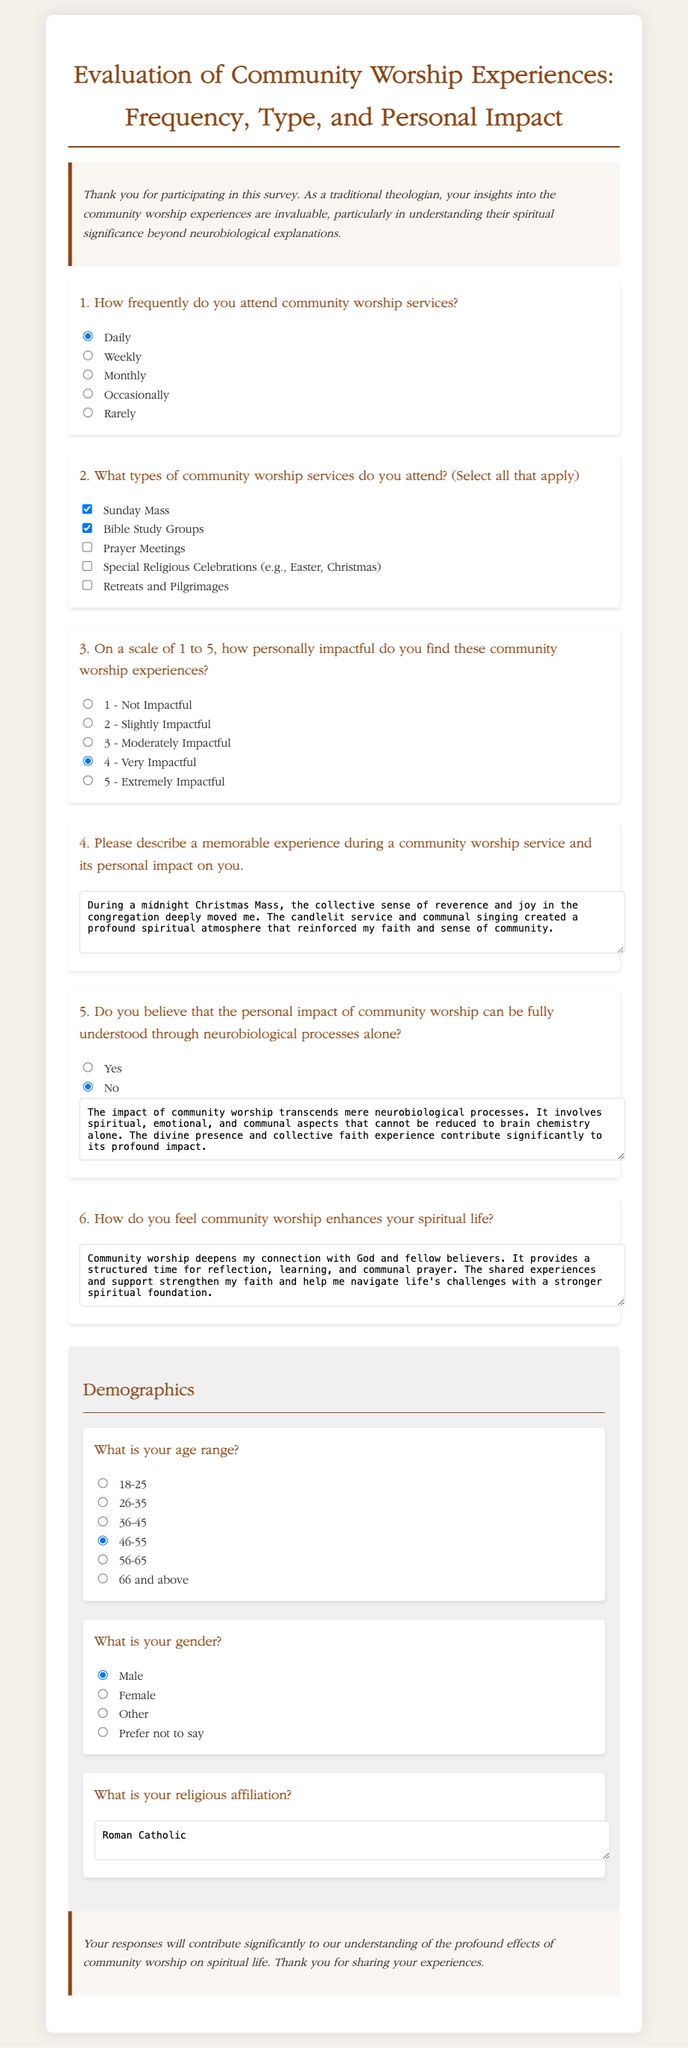How frequently do you attend community worship services? The document provides a question about the attendee's frequency of attending community worship services, listing options such as Daily, Weekly, Monthly, Occasionally, and Rarely.
Answer: Daily What types of community worship services do you attend? The document includes a question asking about different types of community worship services, with options like Sunday Mass and Bible Study Groups available for selection.
Answer: Sunday Mass, Bible Study Groups On a scale of 1 to 5, how personally impactful do you find these community worship experiences? The document includes a question that asks respondents to rate the personal impact of community worship experiences from 1 (Not Impactful) to 5 (Extremely Impactful).
Answer: 4 - Very Impactful What was a memorable experience during a community worship service? The document has a section for respondents to describe memorable experiences during worship services, which provides personal insights into their experiences.
Answer: During a midnight Christmas Mass, the collective sense of reverence and joy in the congregation deeply moved me Do you believe that the personal impact of community worship can be fully understood through neurobiological processes alone? The document includes a question that asks the respondent whether they believe the impact of community worship could be understood solely through neurobiological means, with a response option of Yes or No.
Answer: No What is your age range? The document lists a demographic question regarding the respondent's age, with options ranging from 18-25 to 66 and above.
Answer: 46-55 What is your gender? The document contains a demographic question about the respondent's gender, with options including Male, Female, Other, and Prefer not to say.
Answer: Male What is your religious affiliation? The document asks for the respondent's religious affiliation and includes a space for a short answer.
Answer: Roman Catholic 